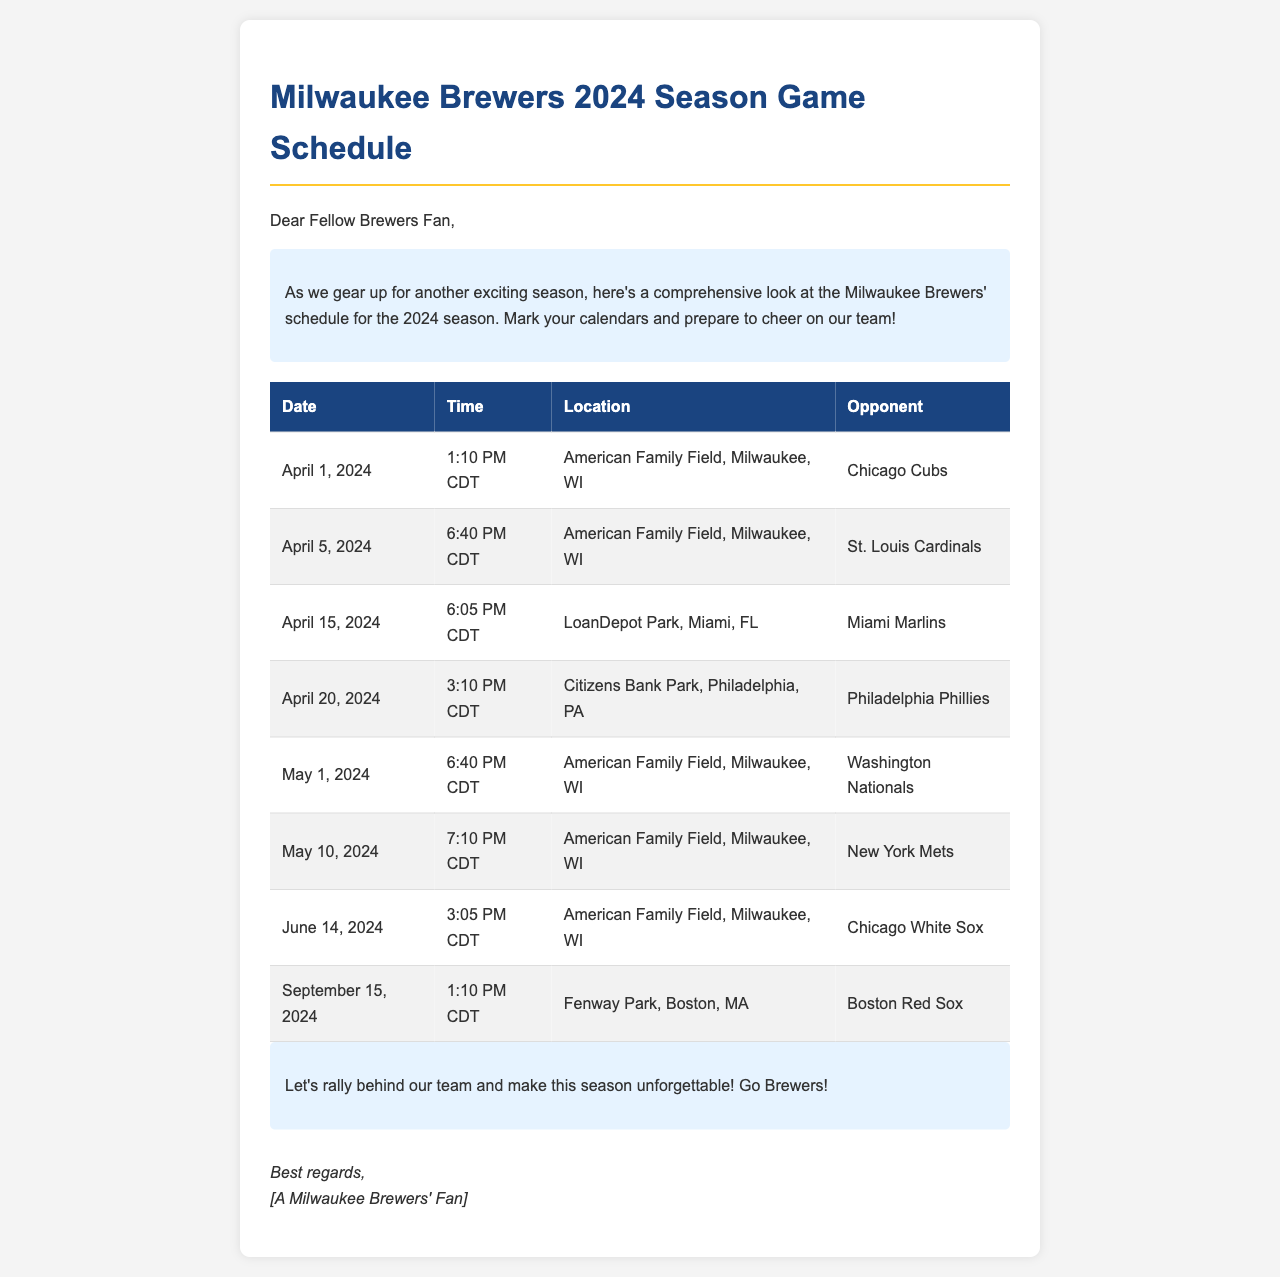What is the first game date of the season? The first game is scheduled for April 1, 2024, according to the table in the document.
Answer: April 1, 2024 What time does the game against the St. Louis Cardinals start? For the game on April 5, 2024, the start time is provided as 6:40 PM CDT.
Answer: 6:40 PM CDT Where will the Brewers play on April 15, 2024? The location for the game on this date is listed as LoanDepot Park, Miami, FL.
Answer: LoanDepot Park, Miami, FL How many home games are listed in the schedule? The document includes home games, specifically on April 1, May 1, May 10, and June 14, totaling four home games.
Answer: 4 Which opponent is scheduled for the last game listed? The final game mentioned is against the Boston Red Sox on September 15, 2024.
Answer: Boston Red Sox What is the time for the game against the Chicago White Sox? The schedule specifies that the game on June 14, 2024, starts at 3:05 PM CDT.
Answer: 3:05 PM CDT How many different opponents do the Brewers face in the schedule? The opponents listed in the schedule include six unique teams: Chicago Cubs, St. Louis Cardinals, Miami Marlins, Philadelphia Phillies, Washington Nationals, New York Mets, and Chicago White Sox.
Answer: 7 What is the closing message to the fans? The document includes a rallying call for fans to support the team in the closing section, emphasizing an unforgettable season.
Answer: Go Brewers! 